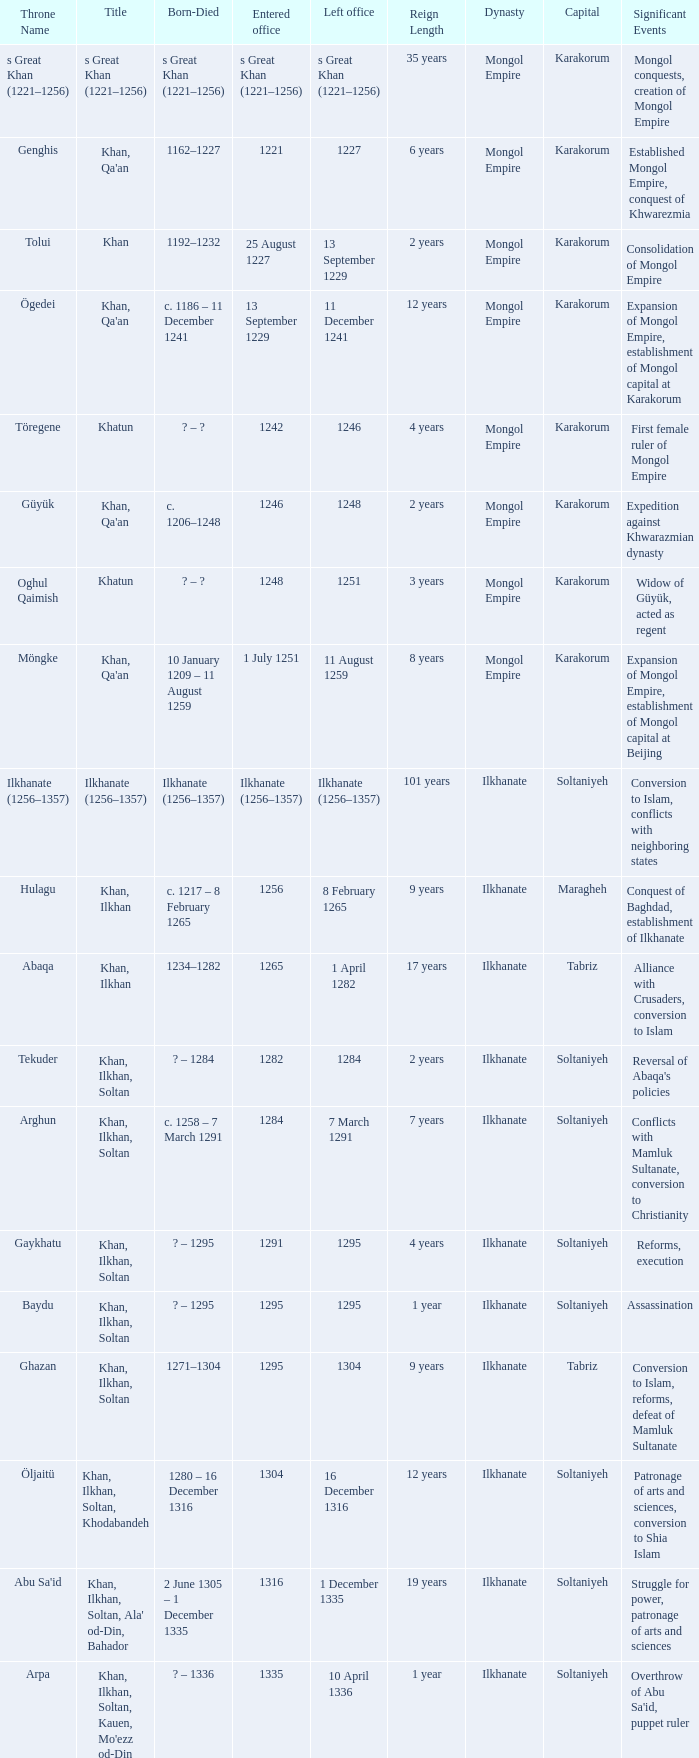What is the entered office that has 1337 as the left office? 12 April 1336. 